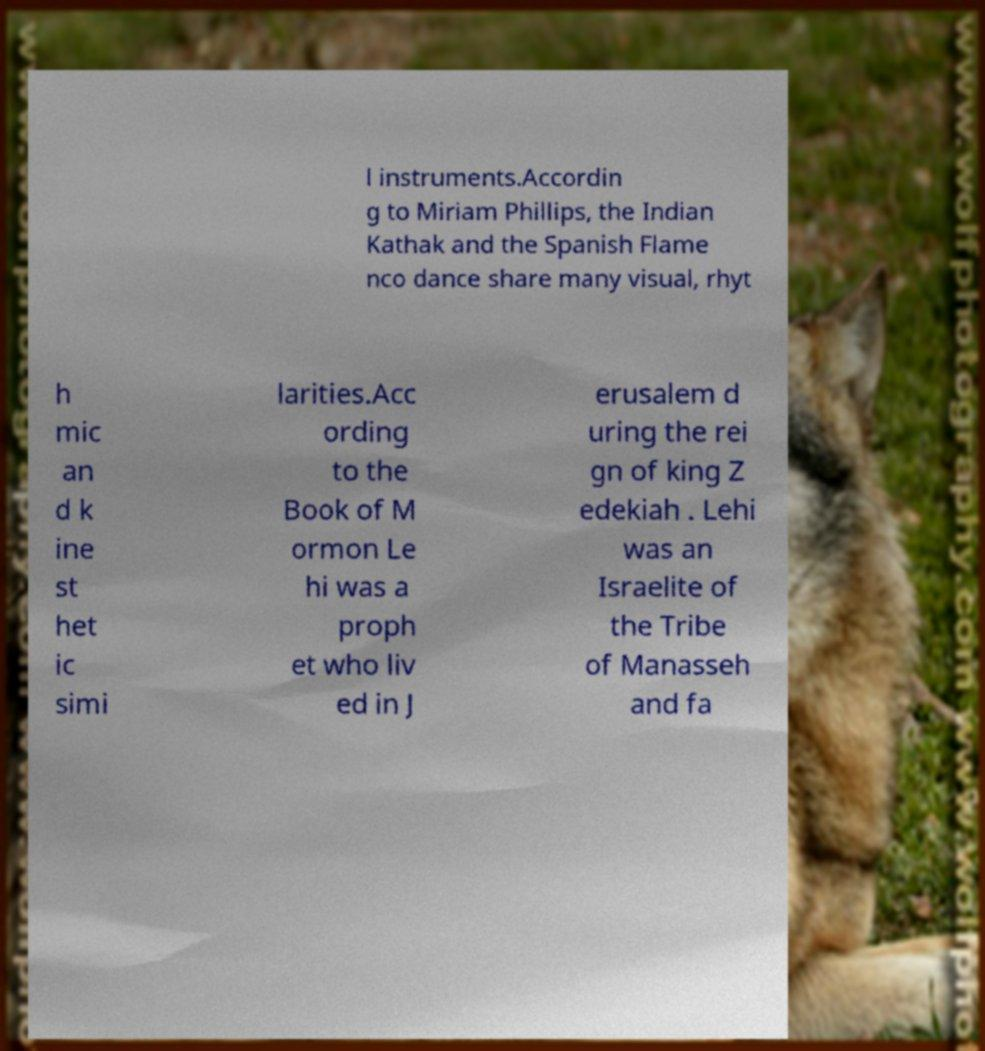Could you extract and type out the text from this image? l instruments.Accordin g to Miriam Phillips, the Indian Kathak and the Spanish Flame nco dance share many visual, rhyt h mic an d k ine st het ic simi larities.Acc ording to the Book of M ormon Le hi was a proph et who liv ed in J erusalem d uring the rei gn of king Z edekiah . Lehi was an Israelite of the Tribe of Manasseh and fa 